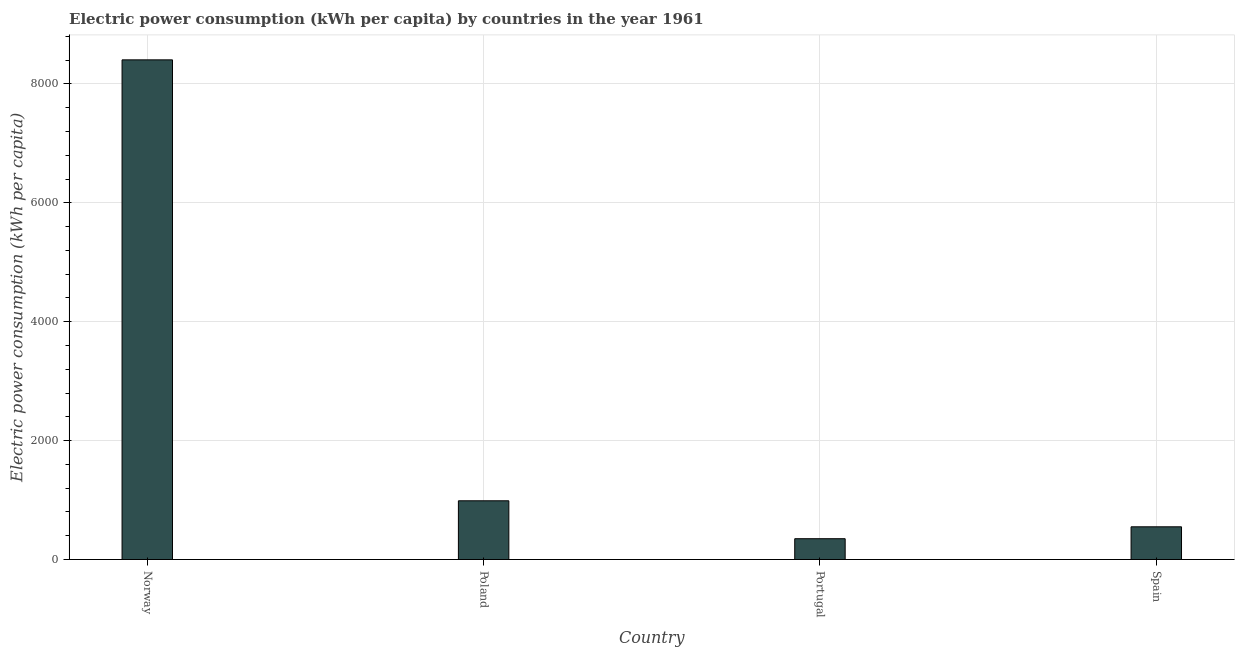Does the graph contain any zero values?
Offer a terse response. No. What is the title of the graph?
Provide a short and direct response. Electric power consumption (kWh per capita) by countries in the year 1961. What is the label or title of the X-axis?
Offer a terse response. Country. What is the label or title of the Y-axis?
Offer a very short reply. Electric power consumption (kWh per capita). What is the electric power consumption in Norway?
Ensure brevity in your answer.  8404.62. Across all countries, what is the maximum electric power consumption?
Give a very brief answer. 8404.62. Across all countries, what is the minimum electric power consumption?
Provide a succinct answer. 350.19. What is the sum of the electric power consumption?
Keep it short and to the point. 1.03e+04. What is the difference between the electric power consumption in Poland and Spain?
Keep it short and to the point. 437.48. What is the average electric power consumption per country?
Your answer should be compact. 2573.29. What is the median electric power consumption?
Offer a very short reply. 769.18. In how many countries, is the electric power consumption greater than 6000 kWh per capita?
Offer a terse response. 1. What is the ratio of the electric power consumption in Poland to that in Spain?
Provide a short and direct response. 1.79. Is the difference between the electric power consumption in Norway and Poland greater than the difference between any two countries?
Keep it short and to the point. No. What is the difference between the highest and the second highest electric power consumption?
Your response must be concise. 7416.7. Is the sum of the electric power consumption in Norway and Portugal greater than the maximum electric power consumption across all countries?
Offer a very short reply. Yes. What is the difference between the highest and the lowest electric power consumption?
Your answer should be compact. 8054.43. In how many countries, is the electric power consumption greater than the average electric power consumption taken over all countries?
Ensure brevity in your answer.  1. Are all the bars in the graph horizontal?
Your answer should be compact. No. How many countries are there in the graph?
Offer a very short reply. 4. Are the values on the major ticks of Y-axis written in scientific E-notation?
Your response must be concise. No. What is the Electric power consumption (kWh per capita) in Norway?
Provide a succinct answer. 8404.62. What is the Electric power consumption (kWh per capita) in Poland?
Provide a succinct answer. 987.92. What is the Electric power consumption (kWh per capita) of Portugal?
Your answer should be very brief. 350.19. What is the Electric power consumption (kWh per capita) of Spain?
Give a very brief answer. 550.44. What is the difference between the Electric power consumption (kWh per capita) in Norway and Poland?
Offer a very short reply. 7416.7. What is the difference between the Electric power consumption (kWh per capita) in Norway and Portugal?
Ensure brevity in your answer.  8054.43. What is the difference between the Electric power consumption (kWh per capita) in Norway and Spain?
Ensure brevity in your answer.  7854.18. What is the difference between the Electric power consumption (kWh per capita) in Poland and Portugal?
Keep it short and to the point. 637.72. What is the difference between the Electric power consumption (kWh per capita) in Poland and Spain?
Make the answer very short. 437.48. What is the difference between the Electric power consumption (kWh per capita) in Portugal and Spain?
Your answer should be compact. -200.24. What is the ratio of the Electric power consumption (kWh per capita) in Norway to that in Poland?
Your response must be concise. 8.51. What is the ratio of the Electric power consumption (kWh per capita) in Norway to that in Spain?
Provide a short and direct response. 15.27. What is the ratio of the Electric power consumption (kWh per capita) in Poland to that in Portugal?
Provide a short and direct response. 2.82. What is the ratio of the Electric power consumption (kWh per capita) in Poland to that in Spain?
Provide a succinct answer. 1.79. What is the ratio of the Electric power consumption (kWh per capita) in Portugal to that in Spain?
Your answer should be compact. 0.64. 